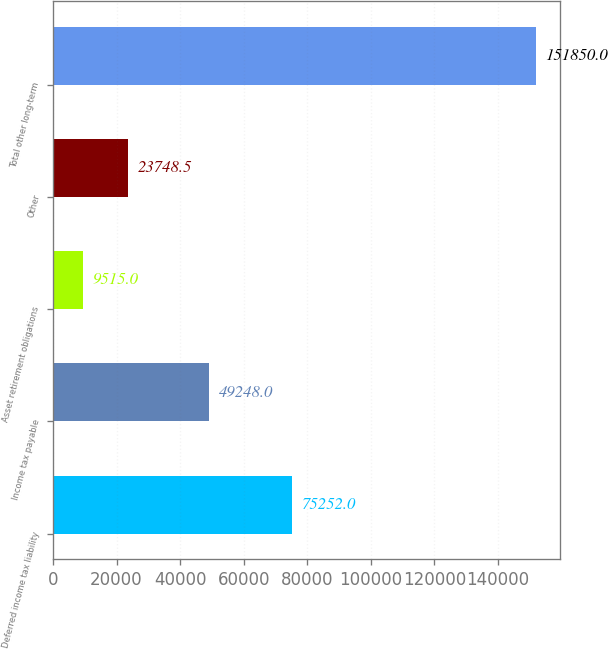<chart> <loc_0><loc_0><loc_500><loc_500><bar_chart><fcel>Deferred income tax liability<fcel>Income tax payable<fcel>Asset retirement obligations<fcel>Other<fcel>Total other long-term<nl><fcel>75252<fcel>49248<fcel>9515<fcel>23748.5<fcel>151850<nl></chart> 